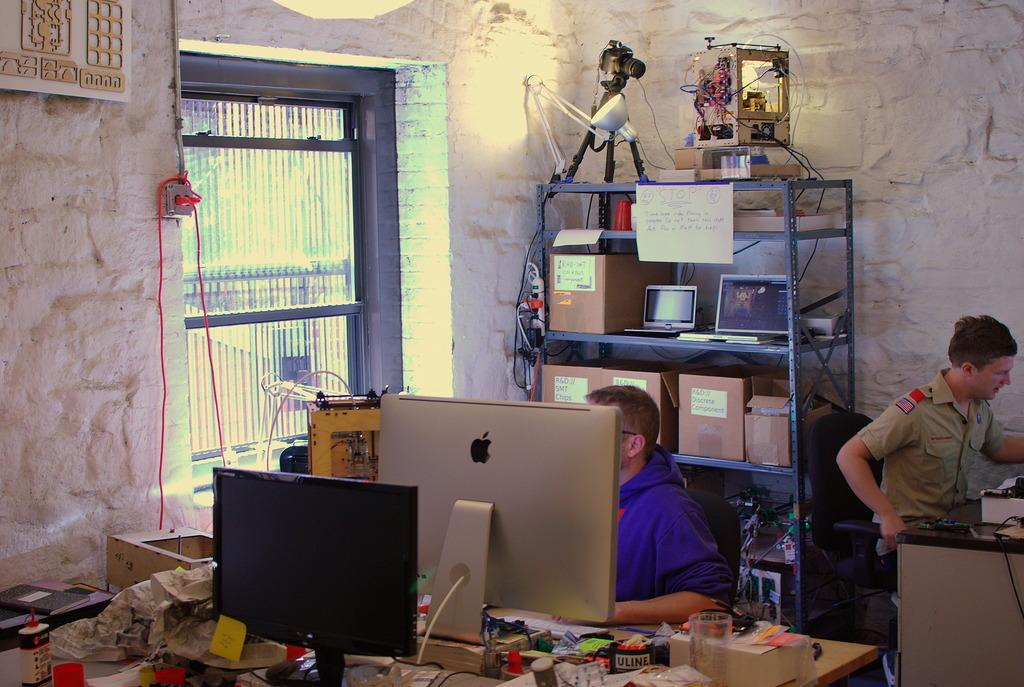How many computers are visible in the image? There are two computers in the image. Who is present in the image? There is a man behind the computers and another person sitting at the right side of the image. What can be seen at the left side of the image? There is a window at the left side of the image. How many kittens are sitting on the man's lap in the image? There are no kittens present in the image; only the man and the computers can be seen. What type of lipstick is the person wearing in the image? There is no indication of lipstick or any makeup in the image, as the focus is on the computers and the people using them. 